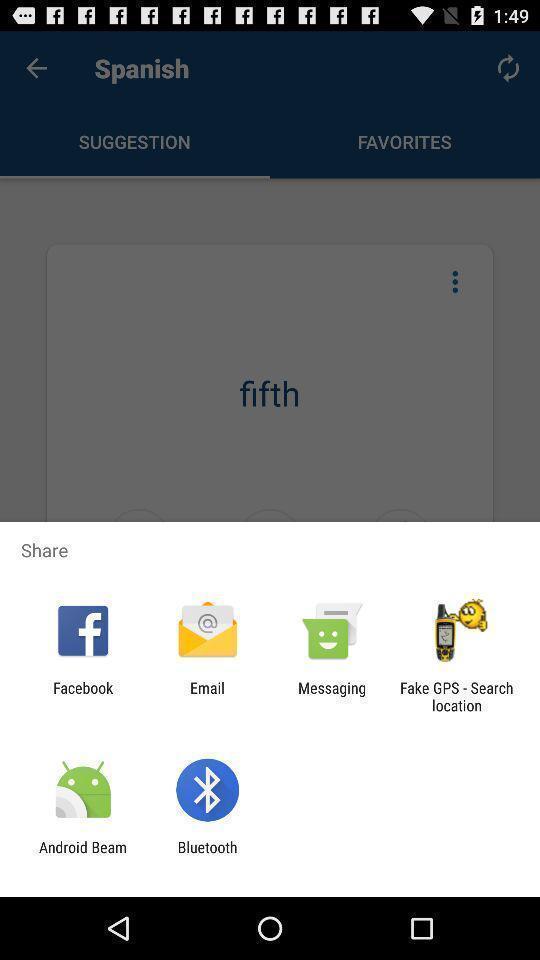Describe the visual elements of this screenshot. Share information with different apps. 